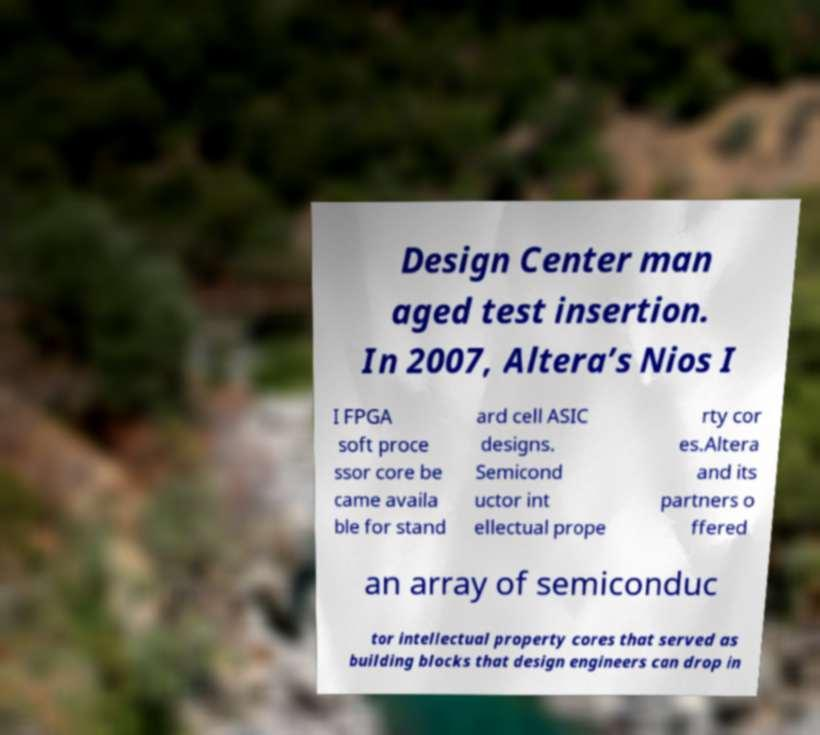Can you accurately transcribe the text from the provided image for me? Design Center man aged test insertion. In 2007, Altera’s Nios I I FPGA soft proce ssor core be came availa ble for stand ard cell ASIC designs. Semicond uctor int ellectual prope rty cor es.Altera and its partners o ffered an array of semiconduc tor intellectual property cores that served as building blocks that design engineers can drop in 